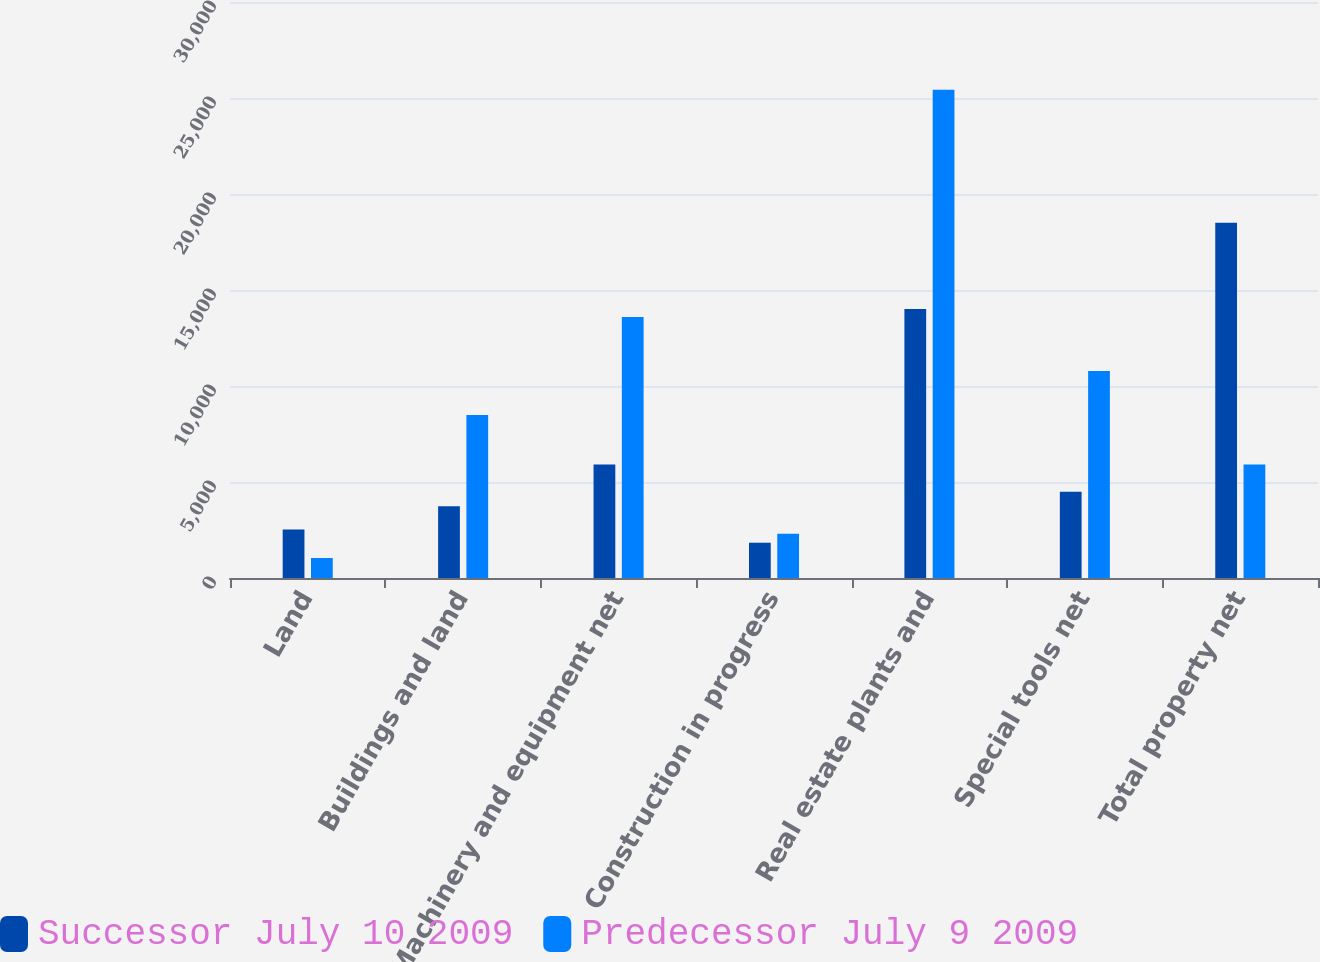Convert chart to OTSL. <chart><loc_0><loc_0><loc_500><loc_500><stacked_bar_chart><ecel><fcel>Land<fcel>Buildings and land<fcel>Machinery and equipment net<fcel>Construction in progress<fcel>Real estate plants and<fcel>Special tools net<fcel>Total property net<nl><fcel>Successor July 10 2009<fcel>2524<fcel>3731<fcel>5915<fcel>1838<fcel>14008<fcel>4492<fcel>18500<nl><fcel>Predecessor July 9 2009<fcel>1040<fcel>8490<fcel>13597<fcel>2307<fcel>25434<fcel>10782<fcel>5915<nl></chart> 